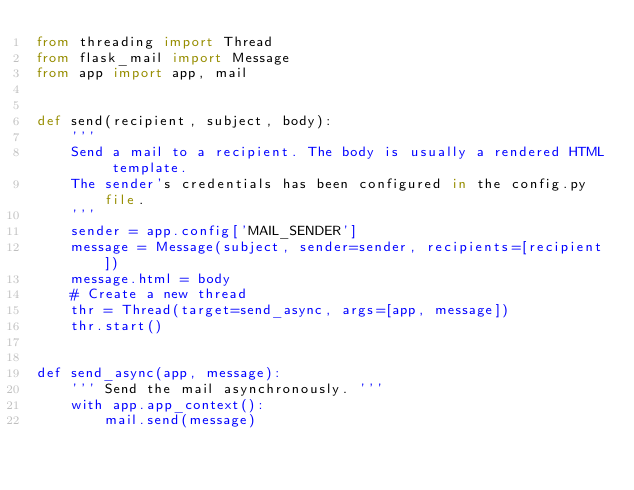Convert code to text. <code><loc_0><loc_0><loc_500><loc_500><_Python_>from threading import Thread
from flask_mail import Message
from app import app, mail


def send(recipient, subject, body):
    '''
    Send a mail to a recipient. The body is usually a rendered HTML template.
    The sender's credentials has been configured in the config.py file.
    '''
    sender = app.config['MAIL_SENDER']
    message = Message(subject, sender=sender, recipients=[recipient])
    message.html = body
    # Create a new thread
    thr = Thread(target=send_async, args=[app, message])
    thr.start()


def send_async(app, message):
    ''' Send the mail asynchronously. '''
    with app.app_context():
        mail.send(message)
</code> 